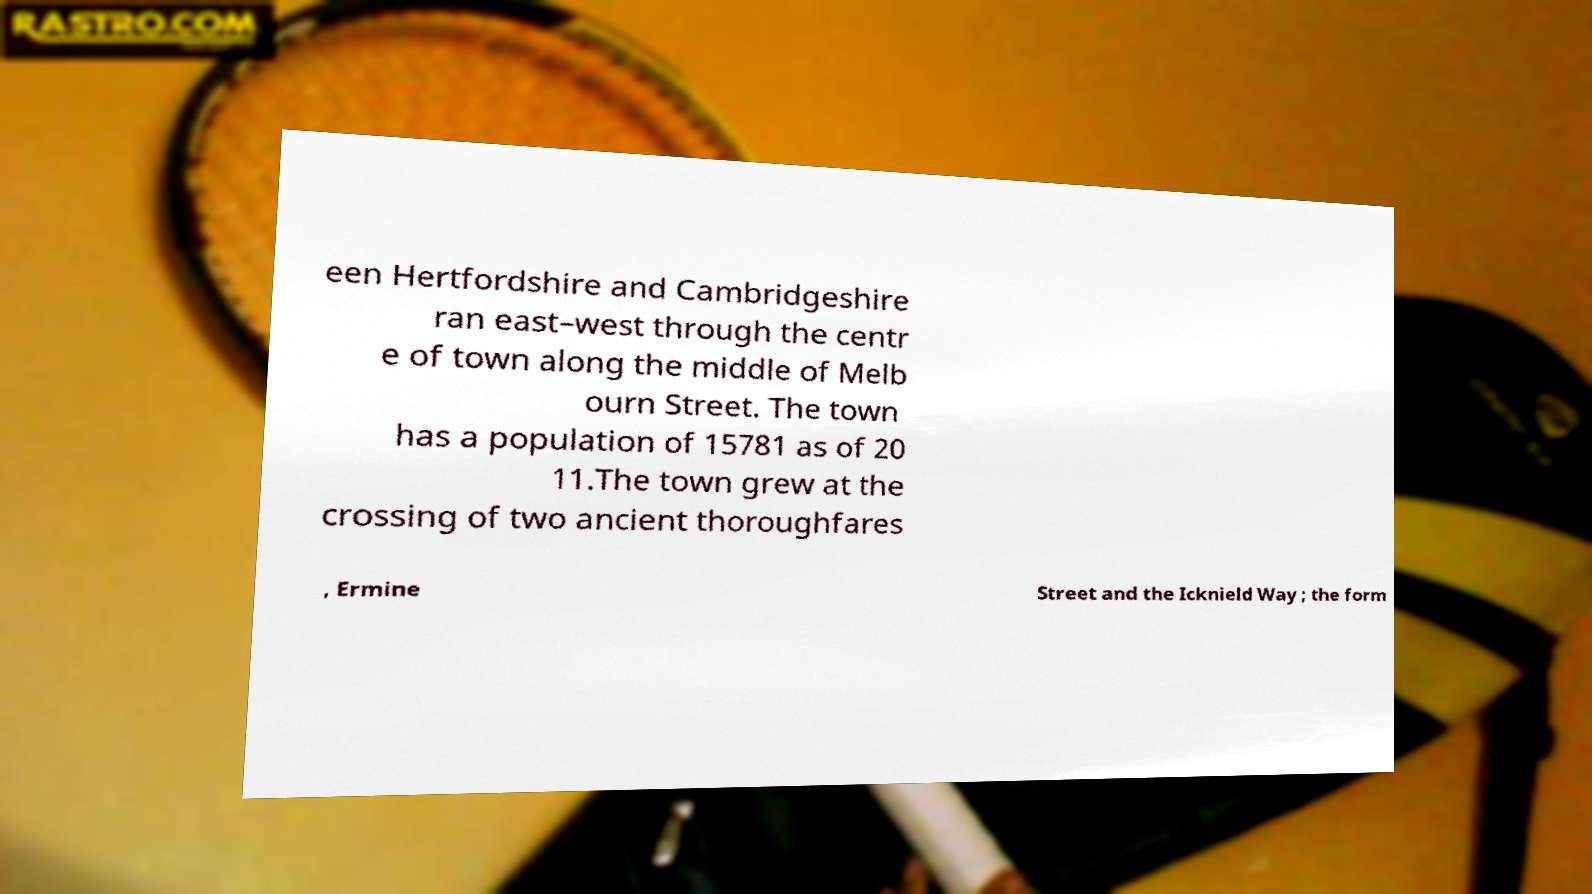I need the written content from this picture converted into text. Can you do that? een Hertfordshire and Cambridgeshire ran east–west through the centr e of town along the middle of Melb ourn Street. The town has a population of 15781 as of 20 11.The town grew at the crossing of two ancient thoroughfares , Ermine Street and the Icknield Way ; the form 